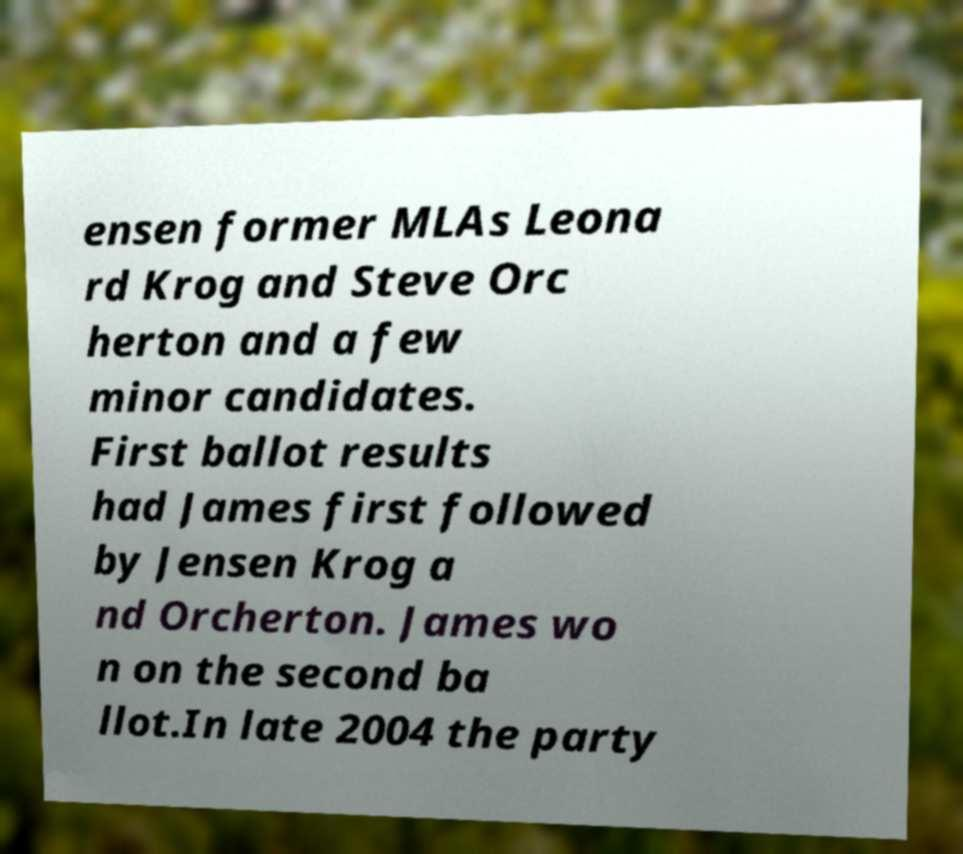Could you assist in decoding the text presented in this image and type it out clearly? ensen former MLAs Leona rd Krog and Steve Orc herton and a few minor candidates. First ballot results had James first followed by Jensen Krog a nd Orcherton. James wo n on the second ba llot.In late 2004 the party 